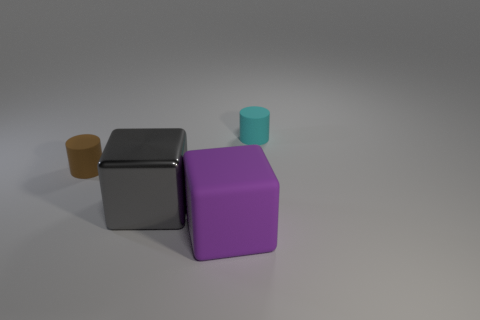What is the color of the metal block?
Your answer should be very brief. Gray. What number of other things are there of the same material as the large purple thing
Ensure brevity in your answer.  2. What number of brown objects are small things or big rubber balls?
Keep it short and to the point. 1. Do the small thing in front of the small cyan rubber cylinder and the matte thing that is behind the brown thing have the same shape?
Ensure brevity in your answer.  Yes. There is a big metal block; is it the same color as the cylinder that is right of the small brown cylinder?
Your answer should be very brief. No. There is a small cylinder that is behind the brown matte cylinder; is its color the same as the big metallic cube?
Provide a succinct answer. No. What number of objects are either cyan objects or objects that are on the right side of the tiny brown cylinder?
Keep it short and to the point. 3. There is a thing that is on the left side of the large rubber block and behind the gray thing; what material is it?
Ensure brevity in your answer.  Rubber. There is a cylinder right of the gray shiny cube; what is it made of?
Your answer should be very brief. Rubber. The cylinder that is made of the same material as the cyan object is what color?
Your response must be concise. Brown. 